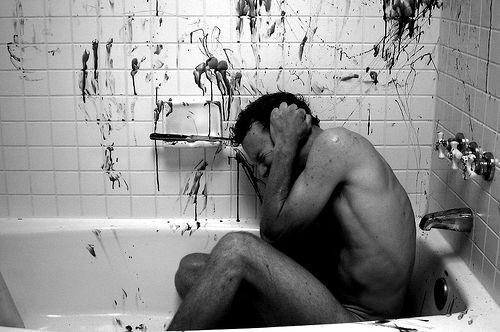Question: how many people are in the photo?
Choices:
A. 1.
B. 2.
C. 3.
D. 6.
Answer with the letter. Answer: A Question: what is the man doing?
Choices:
A. Standing.
B. Running.
C. Jumping.
D. Cowering.
Answer with the letter. Answer: D Question: what is on the soap holder?
Choices:
A. Fork.
B. Knife.
C. Spoon.
D. Scissors.
Answer with the letter. Answer: B Question: where is this shot at?
Choices:
A. Bedroom.
B. Kitchen.
C. Living room.
D. Bathroom.
Answer with the letter. Answer: D 